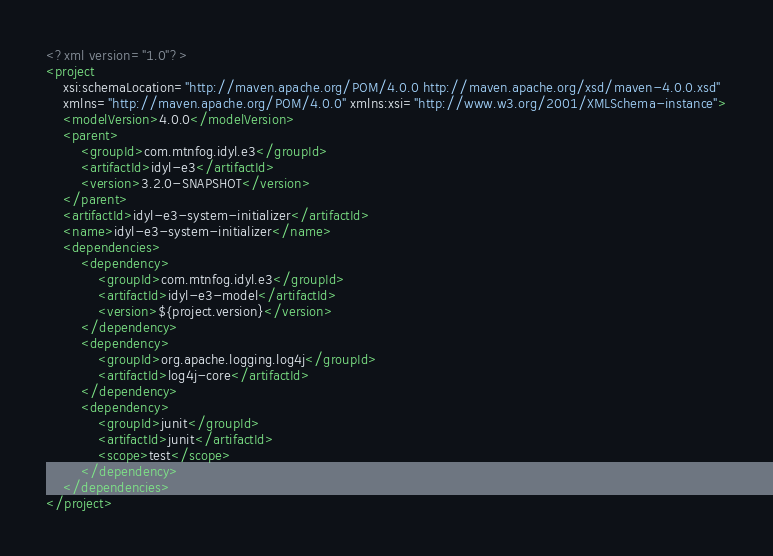Convert code to text. <code><loc_0><loc_0><loc_500><loc_500><_XML_><?xml version="1.0"?>
<project
	xsi:schemaLocation="http://maven.apache.org/POM/4.0.0 http://maven.apache.org/xsd/maven-4.0.0.xsd"
	xmlns="http://maven.apache.org/POM/4.0.0" xmlns:xsi="http://www.w3.org/2001/XMLSchema-instance">
	<modelVersion>4.0.0</modelVersion>
	<parent>
		<groupId>com.mtnfog.idyl.e3</groupId>
		<artifactId>idyl-e3</artifactId>
		<version>3.2.0-SNAPSHOT</version>
	</parent>
	<artifactId>idyl-e3-system-initializer</artifactId>
	<name>idyl-e3-system-initializer</name>
	<dependencies>
		<dependency>
			<groupId>com.mtnfog.idyl.e3</groupId>
			<artifactId>idyl-e3-model</artifactId>
			<version>${project.version}</version>
		</dependency>
		<dependency>
			<groupId>org.apache.logging.log4j</groupId>
			<artifactId>log4j-core</artifactId>
		</dependency>
		<dependency>
			<groupId>junit</groupId>
			<artifactId>junit</artifactId>
			<scope>test</scope>
		</dependency>
	</dependencies>
</project>
</code> 